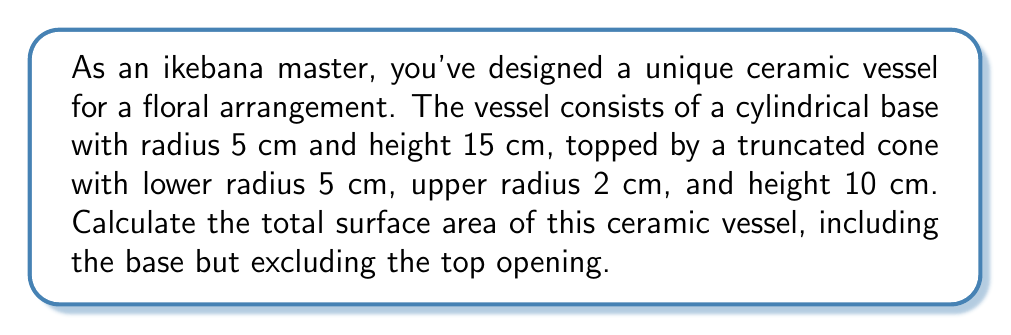Can you solve this math problem? Let's break this down step-by-step:

1) For the cylindrical base:
   - Lateral surface area: $A_{cyl} = 2\pi rh$
   - Base area: $A_{base} = \pi r^2$
   
   $$A_{cyl} = 2\pi(5)(15) = 150\pi \text{ cm}^2$$
   $$A_{base} = \pi(5^2) = 25\pi \text{ cm}^2$$

2) For the truncated cone:
   - We need to calculate the slant height (s) using the Pythagorean theorem:
     $$s = \sqrt{h^2 + (R-r)^2} = \sqrt{10^2 + (5-2)^2} = \sqrt{109} \text{ cm}$$
   
   - Lateral surface area of truncated cone: $A_{trunc} = \pi(R+r)s$
     $$A_{trunc} = \pi(5+2)\sqrt{109} = 7\pi\sqrt{109} \text{ cm}^2$$

3) Total surface area:
   $$A_{total} = A_{cyl} + A_{base} + A_{trunc}$$
   $$A_{total} = 150\pi + 25\pi + 7\pi\sqrt{109}$$
   $$A_{total} = \pi(175 + 7\sqrt{109}) \text{ cm}^2$$
Answer: $\pi(175 + 7\sqrt{109}) \text{ cm}^2$ 